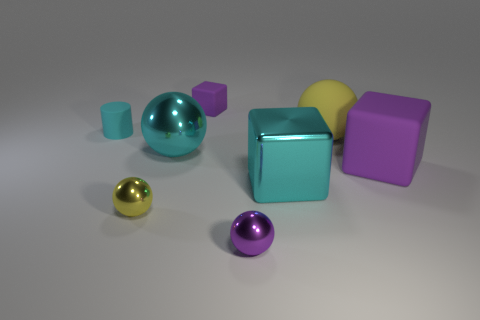Subtract all matte cubes. How many cubes are left? 1 Subtract all yellow cylinders. How many yellow spheres are left? 2 Add 1 cyan metallic things. How many objects exist? 9 Subtract all purple blocks. How many blocks are left? 1 Subtract 0 gray blocks. How many objects are left? 8 Subtract all cylinders. How many objects are left? 7 Subtract 1 cylinders. How many cylinders are left? 0 Subtract all cyan balls. Subtract all blue blocks. How many balls are left? 3 Subtract all large green rubber cylinders. Subtract all cyan cylinders. How many objects are left? 7 Add 6 tiny yellow metallic things. How many tiny yellow metallic things are left? 7 